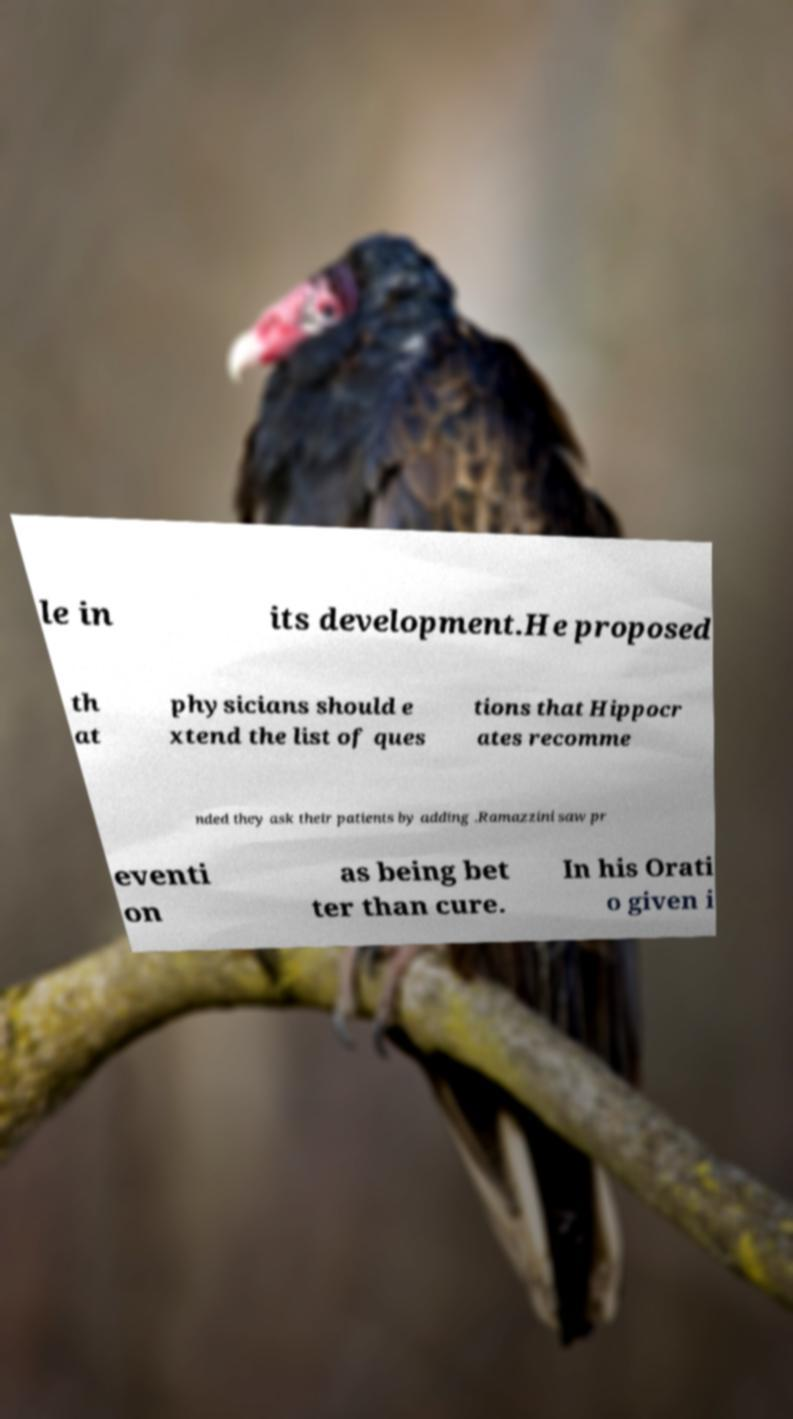Please identify and transcribe the text found in this image. le in its development.He proposed th at physicians should e xtend the list of ques tions that Hippocr ates recomme nded they ask their patients by adding .Ramazzini saw pr eventi on as being bet ter than cure. In his Orati o given i 